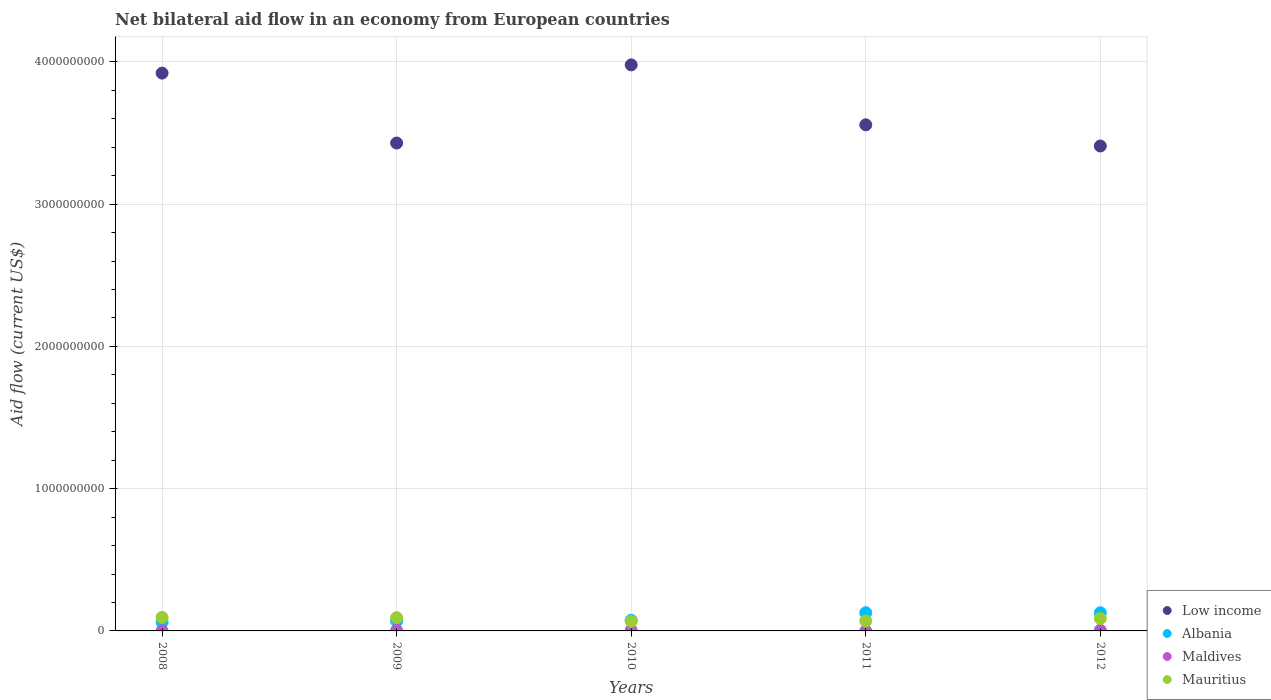How many different coloured dotlines are there?
Give a very brief answer. 4. Is the number of dotlines equal to the number of legend labels?
Offer a very short reply. Yes. What is the net bilateral aid flow in Low income in 2010?
Your answer should be compact. 3.98e+09. Across all years, what is the maximum net bilateral aid flow in Mauritius?
Your answer should be compact. 9.50e+07. In which year was the net bilateral aid flow in Maldives maximum?
Give a very brief answer. 2010. What is the total net bilateral aid flow in Maldives in the graph?
Give a very brief answer. 1.53e+07. What is the difference between the net bilateral aid flow in Albania in 2011 and that in 2012?
Offer a very short reply. 3.70e+05. What is the difference between the net bilateral aid flow in Low income in 2011 and the net bilateral aid flow in Mauritius in 2008?
Make the answer very short. 3.46e+09. What is the average net bilateral aid flow in Mauritius per year?
Your response must be concise. 8.27e+07. In the year 2011, what is the difference between the net bilateral aid flow in Low income and net bilateral aid flow in Albania?
Your answer should be compact. 3.43e+09. What is the ratio of the net bilateral aid flow in Albania in 2011 to that in 2012?
Your response must be concise. 1. Is the difference between the net bilateral aid flow in Low income in 2008 and 2010 greater than the difference between the net bilateral aid flow in Albania in 2008 and 2010?
Keep it short and to the point. No. What is the difference between the highest and the second highest net bilateral aid flow in Maldives?
Make the answer very short. 9.10e+05. What is the difference between the highest and the lowest net bilateral aid flow in Low income?
Offer a terse response. 5.70e+08. In how many years, is the net bilateral aid flow in Mauritius greater than the average net bilateral aid flow in Mauritius taken over all years?
Offer a very short reply. 3. Is the sum of the net bilateral aid flow in Maldives in 2010 and 2012 greater than the maximum net bilateral aid flow in Albania across all years?
Your answer should be compact. No. Is it the case that in every year, the sum of the net bilateral aid flow in Maldives and net bilateral aid flow in Albania  is greater than the sum of net bilateral aid flow in Mauritius and net bilateral aid flow in Low income?
Provide a succinct answer. No. Is it the case that in every year, the sum of the net bilateral aid flow in Albania and net bilateral aid flow in Maldives  is greater than the net bilateral aid flow in Mauritius?
Keep it short and to the point. No. Does the net bilateral aid flow in Mauritius monotonically increase over the years?
Provide a succinct answer. No. How many years are there in the graph?
Ensure brevity in your answer.  5. Are the values on the major ticks of Y-axis written in scientific E-notation?
Your response must be concise. No. Does the graph contain grids?
Your answer should be compact. Yes. Where does the legend appear in the graph?
Make the answer very short. Bottom right. How are the legend labels stacked?
Make the answer very short. Vertical. What is the title of the graph?
Provide a succinct answer. Net bilateral aid flow in an economy from European countries. Does "Tunisia" appear as one of the legend labels in the graph?
Offer a terse response. No. What is the label or title of the X-axis?
Your answer should be very brief. Years. What is the label or title of the Y-axis?
Give a very brief answer. Aid flow (current US$). What is the Aid flow (current US$) in Low income in 2008?
Give a very brief answer. 3.92e+09. What is the Aid flow (current US$) in Albania in 2008?
Provide a succinct answer. 6.04e+07. What is the Aid flow (current US$) of Maldives in 2008?
Offer a very short reply. 1.15e+06. What is the Aid flow (current US$) in Mauritius in 2008?
Make the answer very short. 9.50e+07. What is the Aid flow (current US$) of Low income in 2009?
Your answer should be compact. 3.43e+09. What is the Aid flow (current US$) in Albania in 2009?
Your response must be concise. 6.93e+07. What is the Aid flow (current US$) of Maldives in 2009?
Provide a succinct answer. 3.77e+06. What is the Aid flow (current US$) of Mauritius in 2009?
Ensure brevity in your answer.  9.32e+07. What is the Aid flow (current US$) in Low income in 2010?
Your response must be concise. 3.98e+09. What is the Aid flow (current US$) in Albania in 2010?
Offer a terse response. 7.50e+07. What is the Aid flow (current US$) in Maldives in 2010?
Give a very brief answer. 5.62e+06. What is the Aid flow (current US$) of Mauritius in 2010?
Provide a succinct answer. 6.79e+07. What is the Aid flow (current US$) in Low income in 2011?
Offer a very short reply. 3.56e+09. What is the Aid flow (current US$) of Albania in 2011?
Your answer should be very brief. 1.28e+08. What is the Aid flow (current US$) in Maldives in 2011?
Keep it short and to the point. 5.00e+04. What is the Aid flow (current US$) of Mauritius in 2011?
Offer a very short reply. 7.03e+07. What is the Aid flow (current US$) in Low income in 2012?
Keep it short and to the point. 3.41e+09. What is the Aid flow (current US$) in Albania in 2012?
Your answer should be compact. 1.28e+08. What is the Aid flow (current US$) in Maldives in 2012?
Offer a very short reply. 4.71e+06. What is the Aid flow (current US$) of Mauritius in 2012?
Give a very brief answer. 8.73e+07. Across all years, what is the maximum Aid flow (current US$) of Low income?
Give a very brief answer. 3.98e+09. Across all years, what is the maximum Aid flow (current US$) of Albania?
Provide a short and direct response. 1.28e+08. Across all years, what is the maximum Aid flow (current US$) in Maldives?
Make the answer very short. 5.62e+06. Across all years, what is the maximum Aid flow (current US$) of Mauritius?
Offer a terse response. 9.50e+07. Across all years, what is the minimum Aid flow (current US$) in Low income?
Keep it short and to the point. 3.41e+09. Across all years, what is the minimum Aid flow (current US$) in Albania?
Your answer should be compact. 6.04e+07. Across all years, what is the minimum Aid flow (current US$) of Mauritius?
Your answer should be very brief. 6.79e+07. What is the total Aid flow (current US$) of Low income in the graph?
Provide a short and direct response. 1.83e+1. What is the total Aid flow (current US$) of Albania in the graph?
Your answer should be compact. 4.60e+08. What is the total Aid flow (current US$) of Maldives in the graph?
Keep it short and to the point. 1.53e+07. What is the total Aid flow (current US$) of Mauritius in the graph?
Provide a succinct answer. 4.14e+08. What is the difference between the Aid flow (current US$) of Low income in 2008 and that in 2009?
Keep it short and to the point. 4.92e+08. What is the difference between the Aid flow (current US$) of Albania in 2008 and that in 2009?
Provide a short and direct response. -8.89e+06. What is the difference between the Aid flow (current US$) in Maldives in 2008 and that in 2009?
Ensure brevity in your answer.  -2.62e+06. What is the difference between the Aid flow (current US$) of Mauritius in 2008 and that in 2009?
Your answer should be compact. 1.82e+06. What is the difference between the Aid flow (current US$) of Low income in 2008 and that in 2010?
Provide a short and direct response. -5.79e+07. What is the difference between the Aid flow (current US$) in Albania in 2008 and that in 2010?
Ensure brevity in your answer.  -1.46e+07. What is the difference between the Aid flow (current US$) in Maldives in 2008 and that in 2010?
Your response must be concise. -4.47e+06. What is the difference between the Aid flow (current US$) in Mauritius in 2008 and that in 2010?
Your response must be concise. 2.71e+07. What is the difference between the Aid flow (current US$) in Low income in 2008 and that in 2011?
Keep it short and to the point. 3.63e+08. What is the difference between the Aid flow (current US$) of Albania in 2008 and that in 2011?
Offer a very short reply. -6.75e+07. What is the difference between the Aid flow (current US$) of Maldives in 2008 and that in 2011?
Provide a short and direct response. 1.10e+06. What is the difference between the Aid flow (current US$) of Mauritius in 2008 and that in 2011?
Your answer should be very brief. 2.47e+07. What is the difference between the Aid flow (current US$) in Low income in 2008 and that in 2012?
Your answer should be very brief. 5.12e+08. What is the difference between the Aid flow (current US$) in Albania in 2008 and that in 2012?
Your response must be concise. -6.72e+07. What is the difference between the Aid flow (current US$) of Maldives in 2008 and that in 2012?
Make the answer very short. -3.56e+06. What is the difference between the Aid flow (current US$) of Mauritius in 2008 and that in 2012?
Keep it short and to the point. 7.70e+06. What is the difference between the Aid flow (current US$) in Low income in 2009 and that in 2010?
Ensure brevity in your answer.  -5.50e+08. What is the difference between the Aid flow (current US$) of Albania in 2009 and that in 2010?
Your response must be concise. -5.67e+06. What is the difference between the Aid flow (current US$) in Maldives in 2009 and that in 2010?
Your answer should be very brief. -1.85e+06. What is the difference between the Aid flow (current US$) of Mauritius in 2009 and that in 2010?
Your response must be concise. 2.53e+07. What is the difference between the Aid flow (current US$) in Low income in 2009 and that in 2011?
Offer a very short reply. -1.28e+08. What is the difference between the Aid flow (current US$) in Albania in 2009 and that in 2011?
Provide a short and direct response. -5.86e+07. What is the difference between the Aid flow (current US$) of Maldives in 2009 and that in 2011?
Keep it short and to the point. 3.72e+06. What is the difference between the Aid flow (current US$) of Mauritius in 2009 and that in 2011?
Provide a short and direct response. 2.28e+07. What is the difference between the Aid flow (current US$) of Low income in 2009 and that in 2012?
Provide a succinct answer. 2.07e+07. What is the difference between the Aid flow (current US$) of Albania in 2009 and that in 2012?
Your answer should be compact. -5.83e+07. What is the difference between the Aid flow (current US$) in Maldives in 2009 and that in 2012?
Provide a succinct answer. -9.40e+05. What is the difference between the Aid flow (current US$) in Mauritius in 2009 and that in 2012?
Keep it short and to the point. 5.88e+06. What is the difference between the Aid flow (current US$) of Low income in 2010 and that in 2011?
Make the answer very short. 4.21e+08. What is the difference between the Aid flow (current US$) of Albania in 2010 and that in 2011?
Make the answer very short. -5.30e+07. What is the difference between the Aid flow (current US$) of Maldives in 2010 and that in 2011?
Offer a very short reply. 5.57e+06. What is the difference between the Aid flow (current US$) in Mauritius in 2010 and that in 2011?
Offer a terse response. -2.44e+06. What is the difference between the Aid flow (current US$) in Low income in 2010 and that in 2012?
Keep it short and to the point. 5.70e+08. What is the difference between the Aid flow (current US$) of Albania in 2010 and that in 2012?
Offer a terse response. -5.26e+07. What is the difference between the Aid flow (current US$) in Maldives in 2010 and that in 2012?
Your answer should be compact. 9.10e+05. What is the difference between the Aid flow (current US$) of Mauritius in 2010 and that in 2012?
Give a very brief answer. -1.94e+07. What is the difference between the Aid flow (current US$) in Low income in 2011 and that in 2012?
Offer a very short reply. 1.49e+08. What is the difference between the Aid flow (current US$) in Maldives in 2011 and that in 2012?
Keep it short and to the point. -4.66e+06. What is the difference between the Aid flow (current US$) in Mauritius in 2011 and that in 2012?
Provide a short and direct response. -1.70e+07. What is the difference between the Aid flow (current US$) in Low income in 2008 and the Aid flow (current US$) in Albania in 2009?
Make the answer very short. 3.85e+09. What is the difference between the Aid flow (current US$) in Low income in 2008 and the Aid flow (current US$) in Maldives in 2009?
Offer a terse response. 3.92e+09. What is the difference between the Aid flow (current US$) of Low income in 2008 and the Aid flow (current US$) of Mauritius in 2009?
Provide a succinct answer. 3.83e+09. What is the difference between the Aid flow (current US$) of Albania in 2008 and the Aid flow (current US$) of Maldives in 2009?
Make the answer very short. 5.66e+07. What is the difference between the Aid flow (current US$) of Albania in 2008 and the Aid flow (current US$) of Mauritius in 2009?
Keep it short and to the point. -3.28e+07. What is the difference between the Aid flow (current US$) of Maldives in 2008 and the Aid flow (current US$) of Mauritius in 2009?
Your answer should be very brief. -9.20e+07. What is the difference between the Aid flow (current US$) of Low income in 2008 and the Aid flow (current US$) of Albania in 2010?
Ensure brevity in your answer.  3.85e+09. What is the difference between the Aid flow (current US$) in Low income in 2008 and the Aid flow (current US$) in Maldives in 2010?
Make the answer very short. 3.92e+09. What is the difference between the Aid flow (current US$) in Low income in 2008 and the Aid flow (current US$) in Mauritius in 2010?
Offer a terse response. 3.85e+09. What is the difference between the Aid flow (current US$) of Albania in 2008 and the Aid flow (current US$) of Maldives in 2010?
Make the answer very short. 5.48e+07. What is the difference between the Aid flow (current US$) of Albania in 2008 and the Aid flow (current US$) of Mauritius in 2010?
Make the answer very short. -7.49e+06. What is the difference between the Aid flow (current US$) in Maldives in 2008 and the Aid flow (current US$) in Mauritius in 2010?
Your response must be concise. -6.67e+07. What is the difference between the Aid flow (current US$) in Low income in 2008 and the Aid flow (current US$) in Albania in 2011?
Keep it short and to the point. 3.79e+09. What is the difference between the Aid flow (current US$) in Low income in 2008 and the Aid flow (current US$) in Maldives in 2011?
Ensure brevity in your answer.  3.92e+09. What is the difference between the Aid flow (current US$) of Low income in 2008 and the Aid flow (current US$) of Mauritius in 2011?
Provide a succinct answer. 3.85e+09. What is the difference between the Aid flow (current US$) in Albania in 2008 and the Aid flow (current US$) in Maldives in 2011?
Give a very brief answer. 6.03e+07. What is the difference between the Aid flow (current US$) of Albania in 2008 and the Aid flow (current US$) of Mauritius in 2011?
Make the answer very short. -9.93e+06. What is the difference between the Aid flow (current US$) in Maldives in 2008 and the Aid flow (current US$) in Mauritius in 2011?
Offer a very short reply. -6.92e+07. What is the difference between the Aid flow (current US$) of Low income in 2008 and the Aid flow (current US$) of Albania in 2012?
Make the answer very short. 3.79e+09. What is the difference between the Aid flow (current US$) of Low income in 2008 and the Aid flow (current US$) of Maldives in 2012?
Ensure brevity in your answer.  3.92e+09. What is the difference between the Aid flow (current US$) in Low income in 2008 and the Aid flow (current US$) in Mauritius in 2012?
Provide a short and direct response. 3.83e+09. What is the difference between the Aid flow (current US$) of Albania in 2008 and the Aid flow (current US$) of Maldives in 2012?
Your answer should be compact. 5.57e+07. What is the difference between the Aid flow (current US$) in Albania in 2008 and the Aid flow (current US$) in Mauritius in 2012?
Ensure brevity in your answer.  -2.69e+07. What is the difference between the Aid flow (current US$) of Maldives in 2008 and the Aid flow (current US$) of Mauritius in 2012?
Your answer should be compact. -8.61e+07. What is the difference between the Aid flow (current US$) of Low income in 2009 and the Aid flow (current US$) of Albania in 2010?
Provide a short and direct response. 3.35e+09. What is the difference between the Aid flow (current US$) of Low income in 2009 and the Aid flow (current US$) of Maldives in 2010?
Give a very brief answer. 3.42e+09. What is the difference between the Aid flow (current US$) of Low income in 2009 and the Aid flow (current US$) of Mauritius in 2010?
Make the answer very short. 3.36e+09. What is the difference between the Aid flow (current US$) of Albania in 2009 and the Aid flow (current US$) of Maldives in 2010?
Your response must be concise. 6.37e+07. What is the difference between the Aid flow (current US$) in Albania in 2009 and the Aid flow (current US$) in Mauritius in 2010?
Provide a succinct answer. 1.40e+06. What is the difference between the Aid flow (current US$) in Maldives in 2009 and the Aid flow (current US$) in Mauritius in 2010?
Make the answer very short. -6.41e+07. What is the difference between the Aid flow (current US$) of Low income in 2009 and the Aid flow (current US$) of Albania in 2011?
Make the answer very short. 3.30e+09. What is the difference between the Aid flow (current US$) of Low income in 2009 and the Aid flow (current US$) of Maldives in 2011?
Keep it short and to the point. 3.43e+09. What is the difference between the Aid flow (current US$) in Low income in 2009 and the Aid flow (current US$) in Mauritius in 2011?
Offer a very short reply. 3.36e+09. What is the difference between the Aid flow (current US$) in Albania in 2009 and the Aid flow (current US$) in Maldives in 2011?
Ensure brevity in your answer.  6.92e+07. What is the difference between the Aid flow (current US$) in Albania in 2009 and the Aid flow (current US$) in Mauritius in 2011?
Your answer should be very brief. -1.04e+06. What is the difference between the Aid flow (current US$) of Maldives in 2009 and the Aid flow (current US$) of Mauritius in 2011?
Your response must be concise. -6.66e+07. What is the difference between the Aid flow (current US$) in Low income in 2009 and the Aid flow (current US$) in Albania in 2012?
Give a very brief answer. 3.30e+09. What is the difference between the Aid flow (current US$) of Low income in 2009 and the Aid flow (current US$) of Maldives in 2012?
Provide a short and direct response. 3.42e+09. What is the difference between the Aid flow (current US$) in Low income in 2009 and the Aid flow (current US$) in Mauritius in 2012?
Your answer should be very brief. 3.34e+09. What is the difference between the Aid flow (current US$) of Albania in 2009 and the Aid flow (current US$) of Maldives in 2012?
Make the answer very short. 6.46e+07. What is the difference between the Aid flow (current US$) in Albania in 2009 and the Aid flow (current US$) in Mauritius in 2012?
Your response must be concise. -1.80e+07. What is the difference between the Aid flow (current US$) in Maldives in 2009 and the Aid flow (current US$) in Mauritius in 2012?
Provide a short and direct response. -8.35e+07. What is the difference between the Aid flow (current US$) in Low income in 2010 and the Aid flow (current US$) in Albania in 2011?
Give a very brief answer. 3.85e+09. What is the difference between the Aid flow (current US$) of Low income in 2010 and the Aid flow (current US$) of Maldives in 2011?
Keep it short and to the point. 3.98e+09. What is the difference between the Aid flow (current US$) in Low income in 2010 and the Aid flow (current US$) in Mauritius in 2011?
Provide a short and direct response. 3.91e+09. What is the difference between the Aid flow (current US$) in Albania in 2010 and the Aid flow (current US$) in Maldives in 2011?
Ensure brevity in your answer.  7.49e+07. What is the difference between the Aid flow (current US$) in Albania in 2010 and the Aid flow (current US$) in Mauritius in 2011?
Offer a very short reply. 4.63e+06. What is the difference between the Aid flow (current US$) in Maldives in 2010 and the Aid flow (current US$) in Mauritius in 2011?
Make the answer very short. -6.47e+07. What is the difference between the Aid flow (current US$) of Low income in 2010 and the Aid flow (current US$) of Albania in 2012?
Your answer should be very brief. 3.85e+09. What is the difference between the Aid flow (current US$) of Low income in 2010 and the Aid flow (current US$) of Maldives in 2012?
Offer a very short reply. 3.97e+09. What is the difference between the Aid flow (current US$) of Low income in 2010 and the Aid flow (current US$) of Mauritius in 2012?
Provide a succinct answer. 3.89e+09. What is the difference between the Aid flow (current US$) in Albania in 2010 and the Aid flow (current US$) in Maldives in 2012?
Provide a succinct answer. 7.02e+07. What is the difference between the Aid flow (current US$) of Albania in 2010 and the Aid flow (current US$) of Mauritius in 2012?
Offer a terse response. -1.23e+07. What is the difference between the Aid flow (current US$) in Maldives in 2010 and the Aid flow (current US$) in Mauritius in 2012?
Give a very brief answer. -8.17e+07. What is the difference between the Aid flow (current US$) of Low income in 2011 and the Aid flow (current US$) of Albania in 2012?
Keep it short and to the point. 3.43e+09. What is the difference between the Aid flow (current US$) in Low income in 2011 and the Aid flow (current US$) in Maldives in 2012?
Make the answer very short. 3.55e+09. What is the difference between the Aid flow (current US$) of Low income in 2011 and the Aid flow (current US$) of Mauritius in 2012?
Make the answer very short. 3.47e+09. What is the difference between the Aid flow (current US$) of Albania in 2011 and the Aid flow (current US$) of Maldives in 2012?
Your answer should be compact. 1.23e+08. What is the difference between the Aid flow (current US$) in Albania in 2011 and the Aid flow (current US$) in Mauritius in 2012?
Provide a short and direct response. 4.06e+07. What is the difference between the Aid flow (current US$) in Maldives in 2011 and the Aid flow (current US$) in Mauritius in 2012?
Your answer should be compact. -8.72e+07. What is the average Aid flow (current US$) of Low income per year?
Your answer should be compact. 3.66e+09. What is the average Aid flow (current US$) of Albania per year?
Give a very brief answer. 9.20e+07. What is the average Aid flow (current US$) of Maldives per year?
Offer a very short reply. 3.06e+06. What is the average Aid flow (current US$) in Mauritius per year?
Keep it short and to the point. 8.27e+07. In the year 2008, what is the difference between the Aid flow (current US$) of Low income and Aid flow (current US$) of Albania?
Provide a succinct answer. 3.86e+09. In the year 2008, what is the difference between the Aid flow (current US$) in Low income and Aid flow (current US$) in Maldives?
Provide a short and direct response. 3.92e+09. In the year 2008, what is the difference between the Aid flow (current US$) in Low income and Aid flow (current US$) in Mauritius?
Your answer should be very brief. 3.83e+09. In the year 2008, what is the difference between the Aid flow (current US$) in Albania and Aid flow (current US$) in Maldives?
Offer a terse response. 5.92e+07. In the year 2008, what is the difference between the Aid flow (current US$) of Albania and Aid flow (current US$) of Mauritius?
Ensure brevity in your answer.  -3.46e+07. In the year 2008, what is the difference between the Aid flow (current US$) in Maldives and Aid flow (current US$) in Mauritius?
Provide a short and direct response. -9.38e+07. In the year 2009, what is the difference between the Aid flow (current US$) of Low income and Aid flow (current US$) of Albania?
Give a very brief answer. 3.36e+09. In the year 2009, what is the difference between the Aid flow (current US$) of Low income and Aid flow (current US$) of Maldives?
Offer a very short reply. 3.43e+09. In the year 2009, what is the difference between the Aid flow (current US$) of Low income and Aid flow (current US$) of Mauritius?
Give a very brief answer. 3.34e+09. In the year 2009, what is the difference between the Aid flow (current US$) in Albania and Aid flow (current US$) in Maldives?
Make the answer very short. 6.55e+07. In the year 2009, what is the difference between the Aid flow (current US$) of Albania and Aid flow (current US$) of Mauritius?
Provide a short and direct response. -2.39e+07. In the year 2009, what is the difference between the Aid flow (current US$) of Maldives and Aid flow (current US$) of Mauritius?
Provide a succinct answer. -8.94e+07. In the year 2010, what is the difference between the Aid flow (current US$) of Low income and Aid flow (current US$) of Albania?
Provide a short and direct response. 3.90e+09. In the year 2010, what is the difference between the Aid flow (current US$) in Low income and Aid flow (current US$) in Maldives?
Offer a terse response. 3.97e+09. In the year 2010, what is the difference between the Aid flow (current US$) of Low income and Aid flow (current US$) of Mauritius?
Offer a very short reply. 3.91e+09. In the year 2010, what is the difference between the Aid flow (current US$) of Albania and Aid flow (current US$) of Maldives?
Offer a very short reply. 6.93e+07. In the year 2010, what is the difference between the Aid flow (current US$) of Albania and Aid flow (current US$) of Mauritius?
Make the answer very short. 7.07e+06. In the year 2010, what is the difference between the Aid flow (current US$) in Maldives and Aid flow (current US$) in Mauritius?
Give a very brief answer. -6.23e+07. In the year 2011, what is the difference between the Aid flow (current US$) of Low income and Aid flow (current US$) of Albania?
Your response must be concise. 3.43e+09. In the year 2011, what is the difference between the Aid flow (current US$) of Low income and Aid flow (current US$) of Maldives?
Your answer should be very brief. 3.56e+09. In the year 2011, what is the difference between the Aid flow (current US$) of Low income and Aid flow (current US$) of Mauritius?
Give a very brief answer. 3.49e+09. In the year 2011, what is the difference between the Aid flow (current US$) in Albania and Aid flow (current US$) in Maldives?
Your answer should be very brief. 1.28e+08. In the year 2011, what is the difference between the Aid flow (current US$) of Albania and Aid flow (current US$) of Mauritius?
Keep it short and to the point. 5.76e+07. In the year 2011, what is the difference between the Aid flow (current US$) of Maldives and Aid flow (current US$) of Mauritius?
Offer a terse response. -7.03e+07. In the year 2012, what is the difference between the Aid flow (current US$) of Low income and Aid flow (current US$) of Albania?
Give a very brief answer. 3.28e+09. In the year 2012, what is the difference between the Aid flow (current US$) of Low income and Aid flow (current US$) of Maldives?
Offer a terse response. 3.40e+09. In the year 2012, what is the difference between the Aid flow (current US$) in Low income and Aid flow (current US$) in Mauritius?
Provide a short and direct response. 3.32e+09. In the year 2012, what is the difference between the Aid flow (current US$) in Albania and Aid flow (current US$) in Maldives?
Keep it short and to the point. 1.23e+08. In the year 2012, what is the difference between the Aid flow (current US$) of Albania and Aid flow (current US$) of Mauritius?
Your answer should be very brief. 4.03e+07. In the year 2012, what is the difference between the Aid flow (current US$) of Maldives and Aid flow (current US$) of Mauritius?
Give a very brief answer. -8.26e+07. What is the ratio of the Aid flow (current US$) of Low income in 2008 to that in 2009?
Make the answer very short. 1.14. What is the ratio of the Aid flow (current US$) of Albania in 2008 to that in 2009?
Keep it short and to the point. 0.87. What is the ratio of the Aid flow (current US$) in Maldives in 2008 to that in 2009?
Your answer should be compact. 0.3. What is the ratio of the Aid flow (current US$) in Mauritius in 2008 to that in 2009?
Offer a very short reply. 1.02. What is the ratio of the Aid flow (current US$) in Low income in 2008 to that in 2010?
Your answer should be very brief. 0.99. What is the ratio of the Aid flow (current US$) of Albania in 2008 to that in 2010?
Give a very brief answer. 0.81. What is the ratio of the Aid flow (current US$) in Maldives in 2008 to that in 2010?
Keep it short and to the point. 0.2. What is the ratio of the Aid flow (current US$) of Mauritius in 2008 to that in 2010?
Give a very brief answer. 1.4. What is the ratio of the Aid flow (current US$) of Low income in 2008 to that in 2011?
Offer a very short reply. 1.1. What is the ratio of the Aid flow (current US$) in Albania in 2008 to that in 2011?
Your answer should be compact. 0.47. What is the ratio of the Aid flow (current US$) of Maldives in 2008 to that in 2011?
Your answer should be very brief. 23. What is the ratio of the Aid flow (current US$) of Mauritius in 2008 to that in 2011?
Provide a succinct answer. 1.35. What is the ratio of the Aid flow (current US$) of Low income in 2008 to that in 2012?
Your answer should be compact. 1.15. What is the ratio of the Aid flow (current US$) of Albania in 2008 to that in 2012?
Make the answer very short. 0.47. What is the ratio of the Aid flow (current US$) of Maldives in 2008 to that in 2012?
Keep it short and to the point. 0.24. What is the ratio of the Aid flow (current US$) of Mauritius in 2008 to that in 2012?
Your answer should be compact. 1.09. What is the ratio of the Aid flow (current US$) of Low income in 2009 to that in 2010?
Provide a succinct answer. 0.86. What is the ratio of the Aid flow (current US$) of Albania in 2009 to that in 2010?
Your answer should be compact. 0.92. What is the ratio of the Aid flow (current US$) of Maldives in 2009 to that in 2010?
Offer a terse response. 0.67. What is the ratio of the Aid flow (current US$) in Mauritius in 2009 to that in 2010?
Your answer should be compact. 1.37. What is the ratio of the Aid flow (current US$) of Albania in 2009 to that in 2011?
Make the answer very short. 0.54. What is the ratio of the Aid flow (current US$) of Maldives in 2009 to that in 2011?
Your answer should be compact. 75.4. What is the ratio of the Aid flow (current US$) of Mauritius in 2009 to that in 2011?
Offer a very short reply. 1.32. What is the ratio of the Aid flow (current US$) of Albania in 2009 to that in 2012?
Offer a very short reply. 0.54. What is the ratio of the Aid flow (current US$) of Maldives in 2009 to that in 2012?
Offer a very short reply. 0.8. What is the ratio of the Aid flow (current US$) in Mauritius in 2009 to that in 2012?
Keep it short and to the point. 1.07. What is the ratio of the Aid flow (current US$) of Low income in 2010 to that in 2011?
Ensure brevity in your answer.  1.12. What is the ratio of the Aid flow (current US$) of Albania in 2010 to that in 2011?
Provide a short and direct response. 0.59. What is the ratio of the Aid flow (current US$) in Maldives in 2010 to that in 2011?
Offer a terse response. 112.4. What is the ratio of the Aid flow (current US$) in Mauritius in 2010 to that in 2011?
Offer a very short reply. 0.97. What is the ratio of the Aid flow (current US$) of Low income in 2010 to that in 2012?
Offer a very short reply. 1.17. What is the ratio of the Aid flow (current US$) of Albania in 2010 to that in 2012?
Provide a succinct answer. 0.59. What is the ratio of the Aid flow (current US$) in Maldives in 2010 to that in 2012?
Ensure brevity in your answer.  1.19. What is the ratio of the Aid flow (current US$) of Mauritius in 2010 to that in 2012?
Provide a short and direct response. 0.78. What is the ratio of the Aid flow (current US$) in Low income in 2011 to that in 2012?
Keep it short and to the point. 1.04. What is the ratio of the Aid flow (current US$) in Maldives in 2011 to that in 2012?
Your answer should be compact. 0.01. What is the ratio of the Aid flow (current US$) of Mauritius in 2011 to that in 2012?
Offer a very short reply. 0.81. What is the difference between the highest and the second highest Aid flow (current US$) of Low income?
Your answer should be compact. 5.79e+07. What is the difference between the highest and the second highest Aid flow (current US$) of Maldives?
Your response must be concise. 9.10e+05. What is the difference between the highest and the second highest Aid flow (current US$) of Mauritius?
Your answer should be very brief. 1.82e+06. What is the difference between the highest and the lowest Aid flow (current US$) in Low income?
Your response must be concise. 5.70e+08. What is the difference between the highest and the lowest Aid flow (current US$) in Albania?
Offer a very short reply. 6.75e+07. What is the difference between the highest and the lowest Aid flow (current US$) of Maldives?
Your response must be concise. 5.57e+06. What is the difference between the highest and the lowest Aid flow (current US$) of Mauritius?
Give a very brief answer. 2.71e+07. 